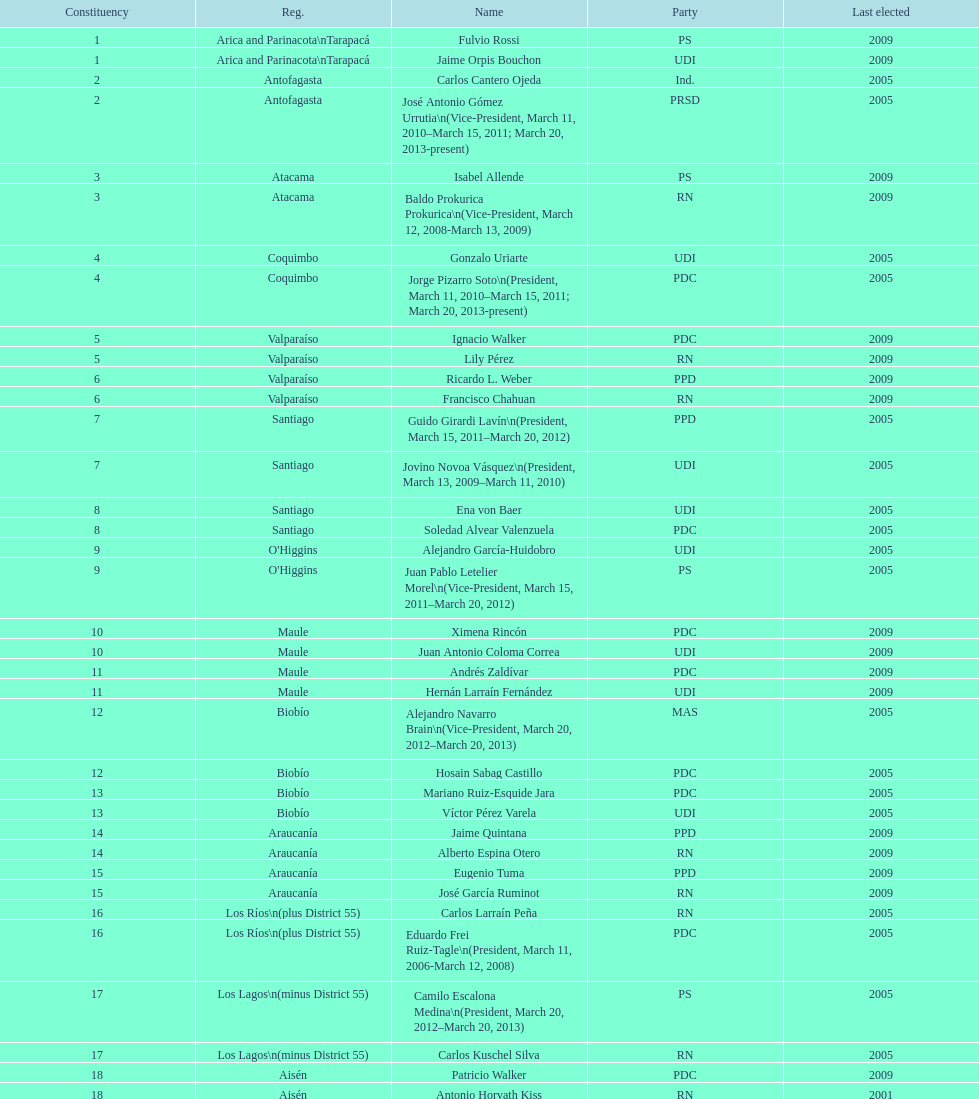What is the total number of constituencies? 19. 